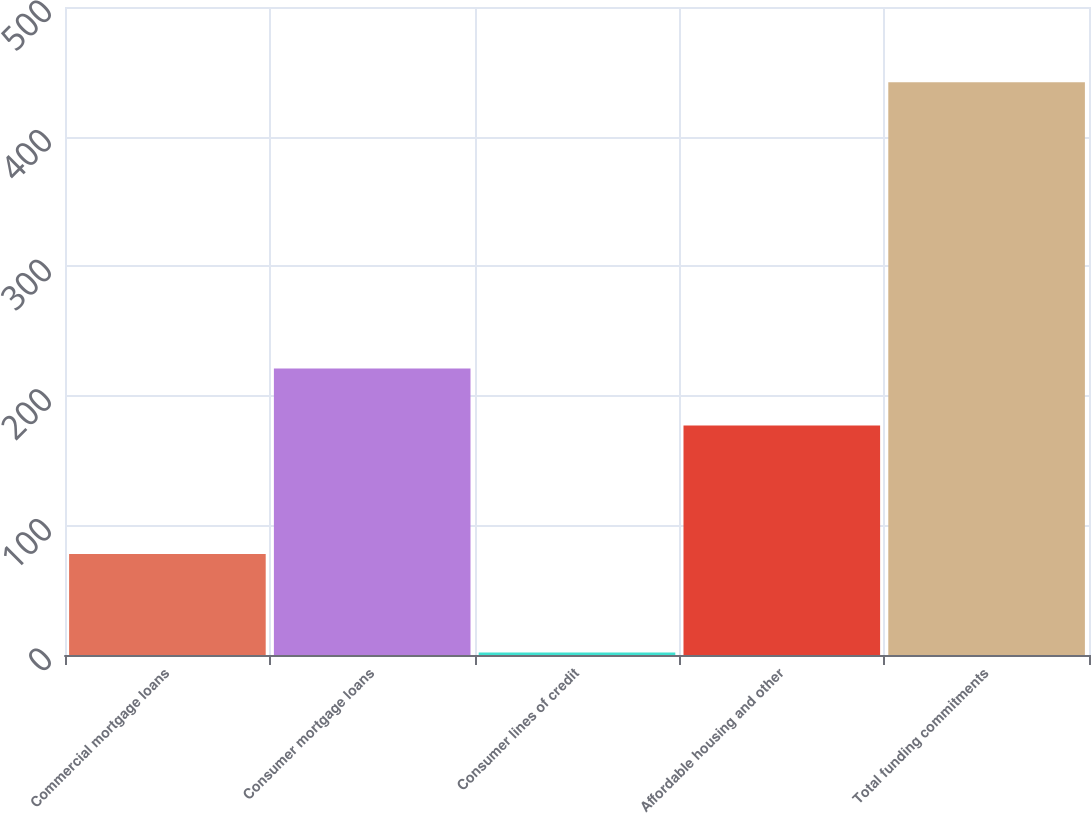Convert chart. <chart><loc_0><loc_0><loc_500><loc_500><bar_chart><fcel>Commercial mortgage loans<fcel>Consumer mortgage loans<fcel>Consumer lines of credit<fcel>Affordable housing and other<fcel>Total funding commitments<nl><fcel>78<fcel>221<fcel>2<fcel>177<fcel>442<nl></chart> 